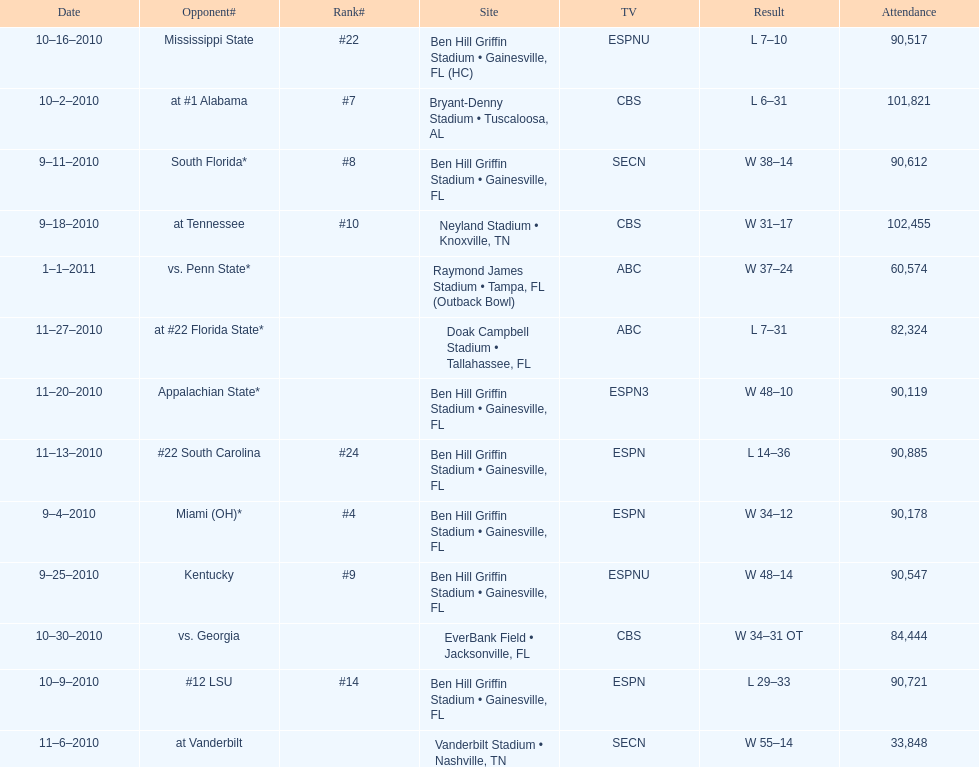The gators won the game on september 25, 2010. who won the previous game? Gators. 